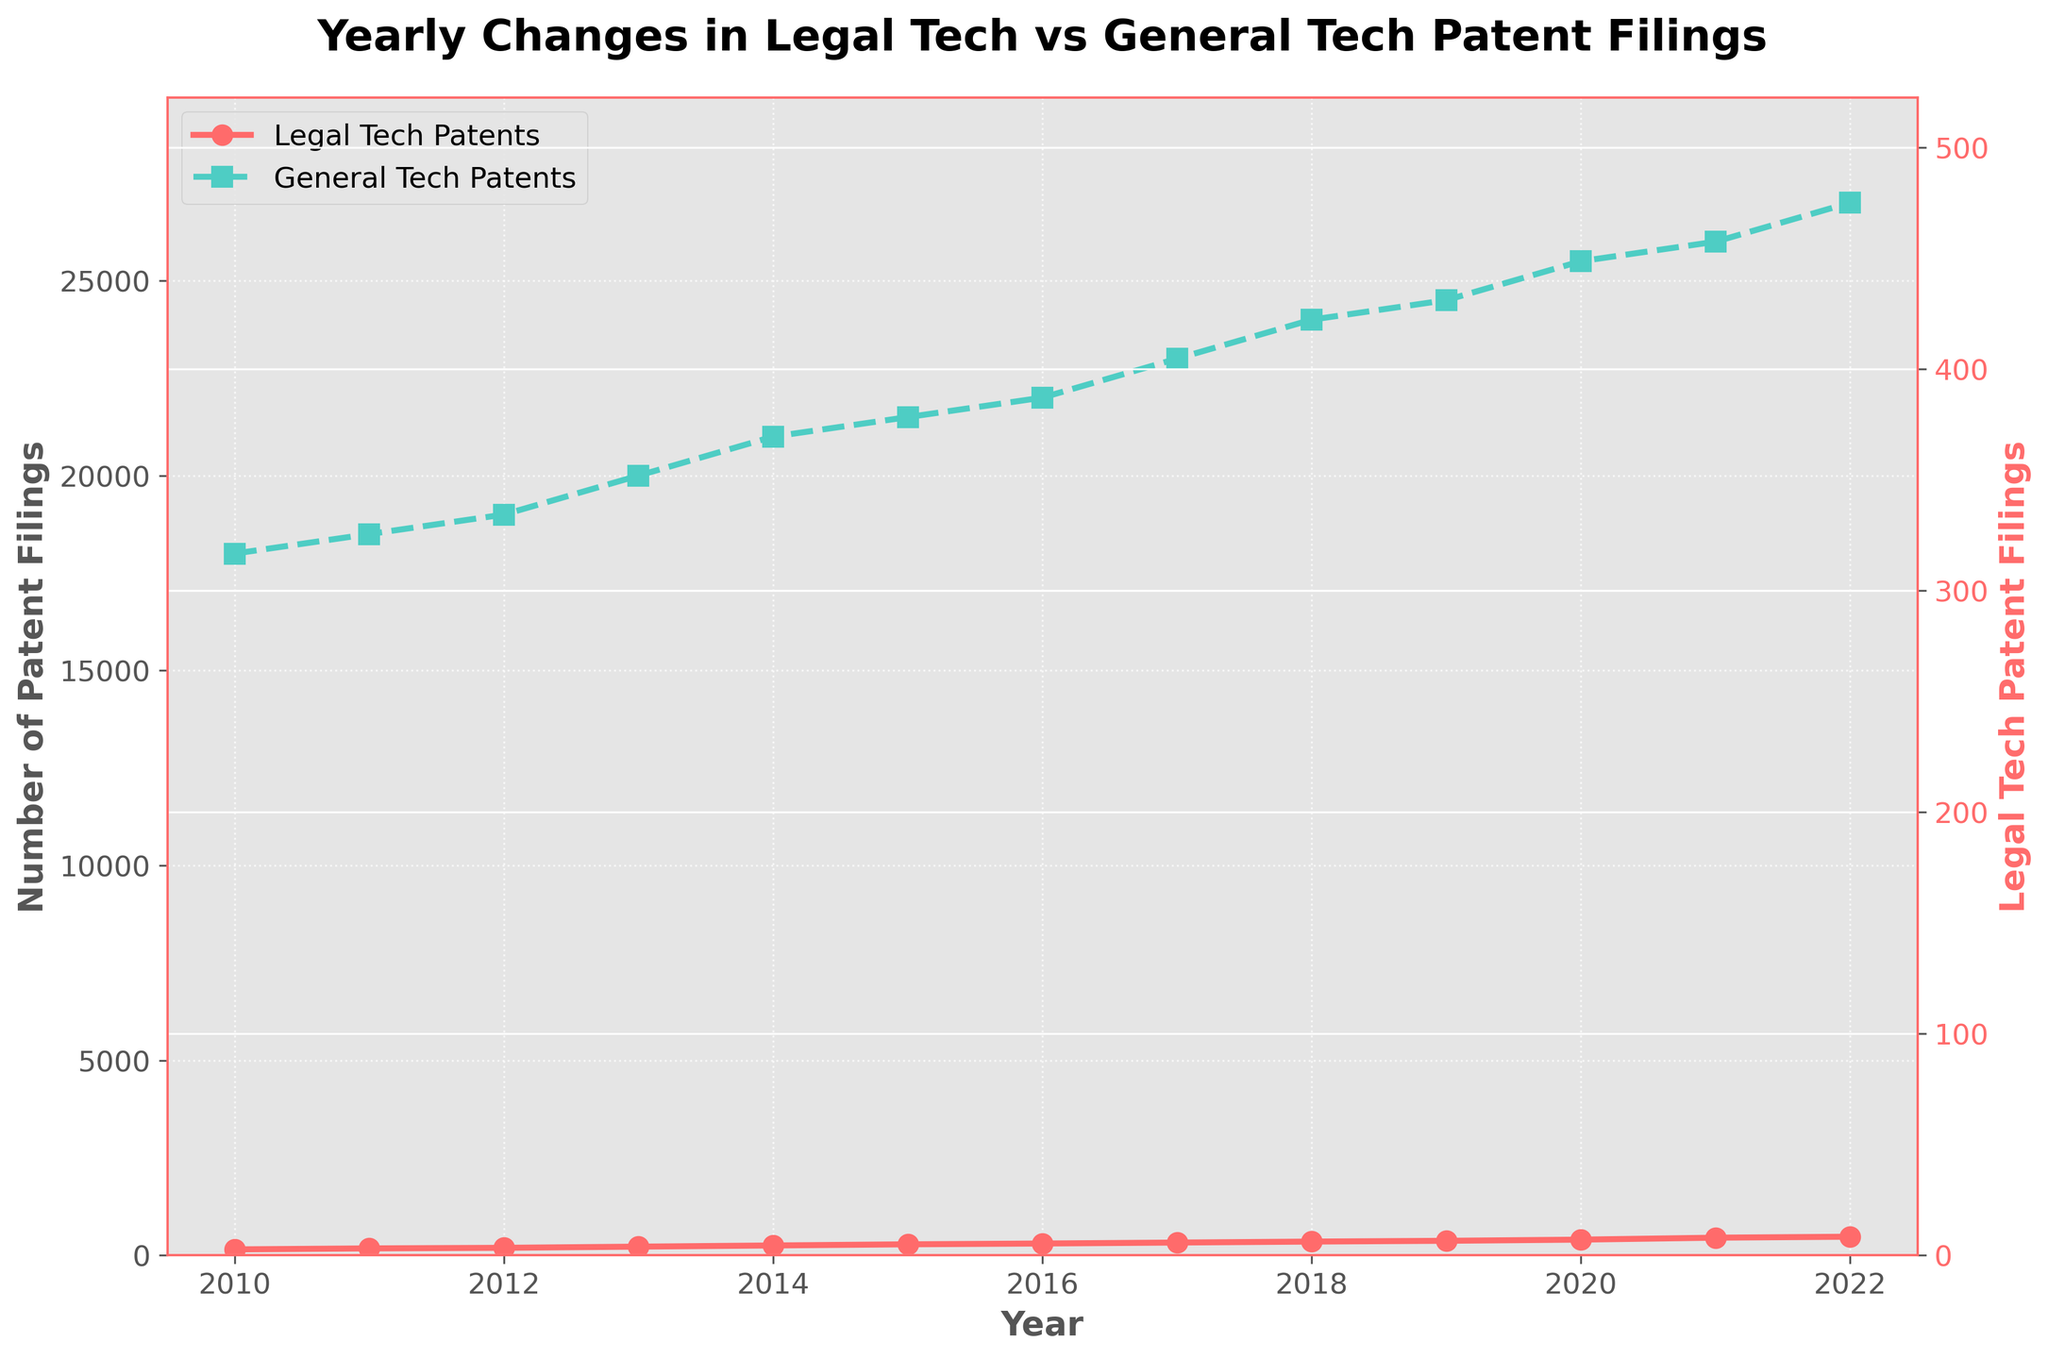What is the trend in Legal Tech patent filings from 2010 to 2022? The trend in Legal Tech patent filings can be observed by looking at the line plot of "Legal Tech Patents." The line starts at 150 in 2010 and ends at 475 in 2022, showing an overall increasing trend.
Answer: Increasing How many Legal Tech patents were filed in 2015? To find the number of Legal Tech patents filed in 2015, locate the point corresponding to 2015 on the "Legal Tech Patents" line. The value is 280.
Answer: 280 What year saw the highest number of General Tech patent filings? To find the year with the highest number of General Tech patent filings, look for the highest point on the "General Tech Patents" line. This occurs in 2022 with 27,000 filings.
Answer: 2022 By how much did Legal Tech patent filings increase from 2010 to 2020? To find the increase, subtract the number of Legal Tech patent filings in 2010 from the number in 2020. This is 400 - 150 = 250.
Answer: 250 Do Legal Tech or General Tech patents grow faster from 2010 to 2022? To determine which grows faster, compare the slopes of the two lines. Legal Tech starts at 150 and increases to 475 (an increase of 325), while General Tech starts at 18,000 and increases to 27,000 (an increase of 9,000). However, the General Tech increase, in terms of percentage, is smaller compared to Legal Tech.
Answer: Legal Tech What is the average number of Legal Tech patent filings from 2010 to 2022? To find the average, sum the values of Legal Tech patent filings for all years and divide by the number of years. The sum is 150 + 175 + 190 + 220 + 250 + 280 + 300 + 325 + 350 + 370 + 400 + 450 + 475 = 3935. Divide by 13 (number of years) to get 3935 / 13 ≈ 302.69.
Answer: 302.69 What year had the smallest difference between Legal Tech and General Tech patent filings? To find the smallest difference, calculate the absolute difference between Legal Tech and General Tech patent filings for each year and find the minimum value. For example, in 2010:
Answer: 2010 Are there any years where the number of General Tech patent filings decreased compared to the previous year? To determine this, look for points where the "General Tech Patents" line goes down compared to the previous point. In this dataset, the line only goes up, indicating no decrease.
Answer: No What was the ratio of Legal Tech to General Tech patent filings in 2022? Calculate the ratio by dividing the number of Legal Tech patent filings by the number of General Tech patent filings in 2022. This is 475 / 27000 ≈ 0.0176.
Answer: 0.0176 How does the overall trend in General Tech patent filings compare to that of Legal Tech patent filings? To compare trends, look at the slopes of the two lines. Both lines are increasing, but Legal Tech filings show a steeper slope (indicating faster growth) compared to General Tech filings, which show a more modest increase.
Answer: Legal Tech grows faster 